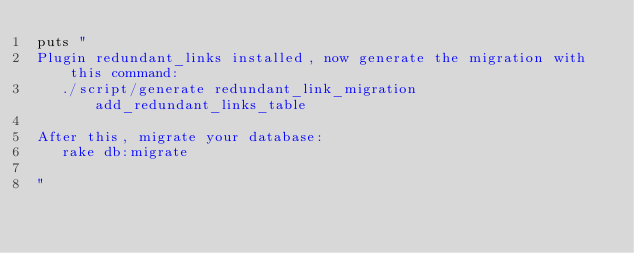Convert code to text. <code><loc_0><loc_0><loc_500><loc_500><_Ruby_>puts "
Plugin redundant_links installed, now generate the migration with this command:
   ./script/generate redundant_link_migration add_redundant_links_table

After this, migrate your database:
   rake db:migrate

"</code> 